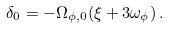Convert formula to latex. <formula><loc_0><loc_0><loc_500><loc_500>\delta _ { 0 } = - \Omega _ { \phi , 0 } ( \xi + 3 \omega _ { \phi } ) \, .</formula> 